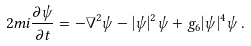<formula> <loc_0><loc_0><loc_500><loc_500>2 m i \frac { \partial \psi } { \partial t } = - \nabla ^ { 2 } \psi - | \psi | ^ { 2 } \psi + g _ { 6 } | \psi | ^ { 4 } \psi \, .</formula> 